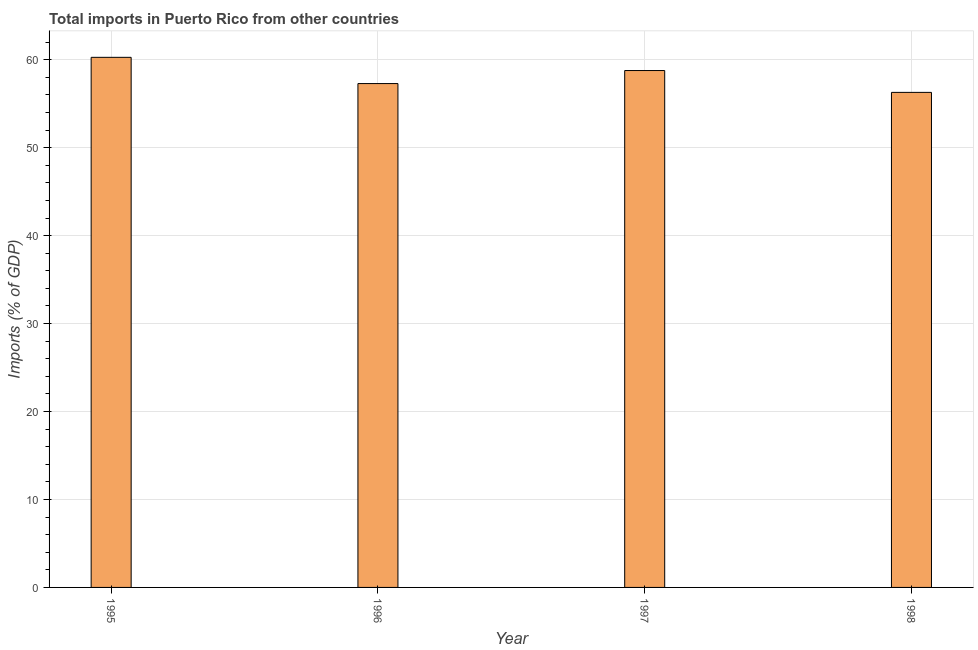Does the graph contain any zero values?
Your answer should be very brief. No. What is the title of the graph?
Make the answer very short. Total imports in Puerto Rico from other countries. What is the label or title of the Y-axis?
Your response must be concise. Imports (% of GDP). What is the total imports in 1997?
Provide a short and direct response. 58.77. Across all years, what is the maximum total imports?
Give a very brief answer. 60.27. Across all years, what is the minimum total imports?
Your answer should be very brief. 56.29. What is the sum of the total imports?
Keep it short and to the point. 232.62. What is the difference between the total imports in 1995 and 1998?
Offer a terse response. 3.99. What is the average total imports per year?
Offer a very short reply. 58.16. What is the median total imports?
Offer a terse response. 58.03. What is the ratio of the total imports in 1997 to that in 1998?
Keep it short and to the point. 1.04. Is the total imports in 1996 less than that in 1997?
Your answer should be compact. Yes. What is the difference between the highest and the second highest total imports?
Ensure brevity in your answer.  1.5. What is the difference between the highest and the lowest total imports?
Your answer should be very brief. 3.99. Are all the bars in the graph horizontal?
Ensure brevity in your answer.  No. Are the values on the major ticks of Y-axis written in scientific E-notation?
Ensure brevity in your answer.  No. What is the Imports (% of GDP) in 1995?
Keep it short and to the point. 60.27. What is the Imports (% of GDP) in 1996?
Ensure brevity in your answer.  57.29. What is the Imports (% of GDP) of 1997?
Your response must be concise. 58.77. What is the Imports (% of GDP) of 1998?
Offer a terse response. 56.29. What is the difference between the Imports (% of GDP) in 1995 and 1996?
Provide a short and direct response. 2.98. What is the difference between the Imports (% of GDP) in 1995 and 1997?
Provide a succinct answer. 1.5. What is the difference between the Imports (% of GDP) in 1995 and 1998?
Make the answer very short. 3.99. What is the difference between the Imports (% of GDP) in 1996 and 1997?
Your response must be concise. -1.48. What is the difference between the Imports (% of GDP) in 1996 and 1998?
Your answer should be compact. 1. What is the difference between the Imports (% of GDP) in 1997 and 1998?
Make the answer very short. 2.48. What is the ratio of the Imports (% of GDP) in 1995 to that in 1996?
Offer a very short reply. 1.05. What is the ratio of the Imports (% of GDP) in 1995 to that in 1998?
Ensure brevity in your answer.  1.07. What is the ratio of the Imports (% of GDP) in 1997 to that in 1998?
Provide a succinct answer. 1.04. 